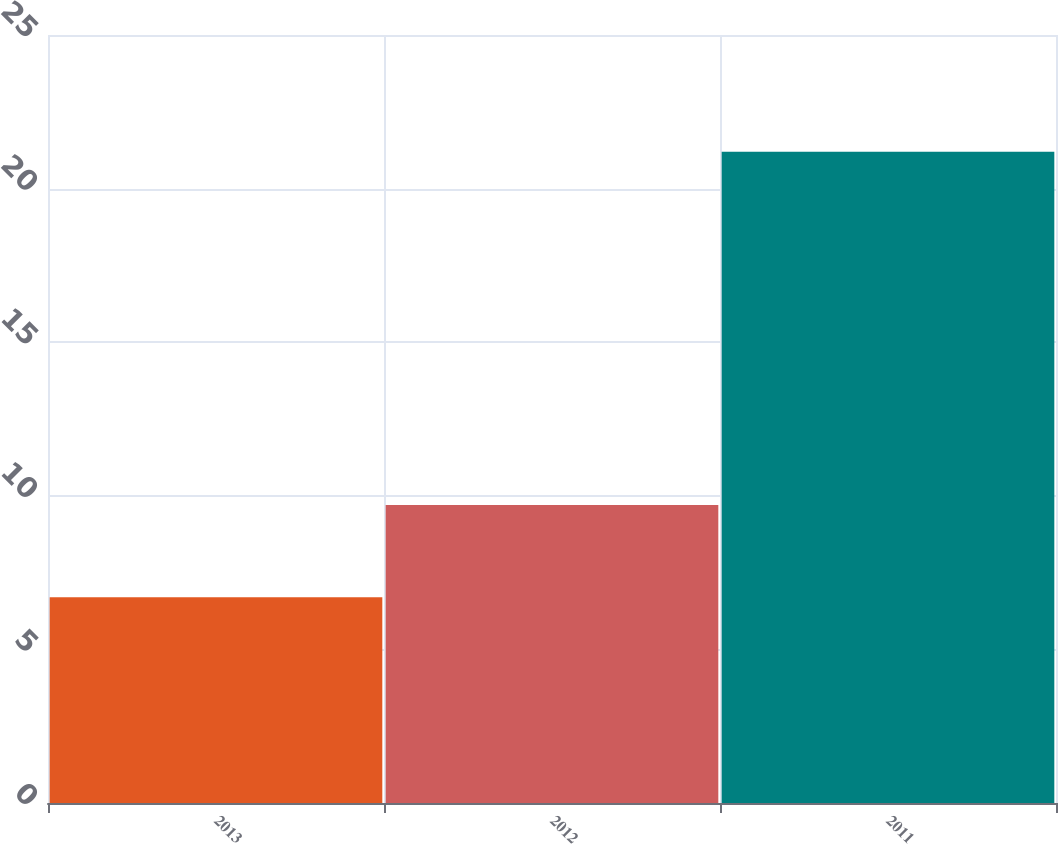<chart> <loc_0><loc_0><loc_500><loc_500><bar_chart><fcel>2013<fcel>2012<fcel>2011<nl><fcel>6.7<fcel>9.7<fcel>21.2<nl></chart> 